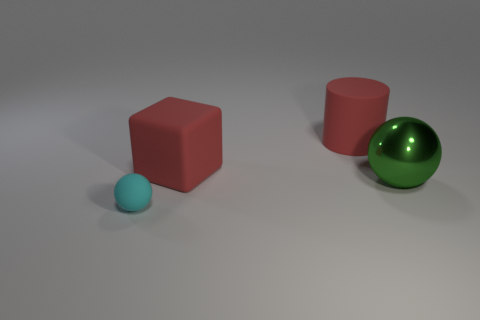Are there any things in front of the big green object?
Your answer should be compact. Yes. What is the color of the ball that is on the right side of the thing that is in front of the sphere that is right of the cyan rubber thing?
Your answer should be very brief. Green. What number of things are behind the tiny cyan sphere and left of the large sphere?
Offer a very short reply. 2. How many cylinders are either big purple objects or cyan objects?
Keep it short and to the point. 0. Are any big yellow balls visible?
Give a very brief answer. No. How many other objects are there of the same material as the cyan object?
Give a very brief answer. 2. What is the material of the ball that is the same size as the red cube?
Provide a short and direct response. Metal. There is a big thing that is in front of the large cube; is its shape the same as the small cyan thing?
Your answer should be very brief. Yes. Does the cube have the same color as the large matte cylinder?
Provide a succinct answer. Yes. How many objects are either red rubber things behind the small cyan ball or small cyan balls?
Provide a succinct answer. 3. 